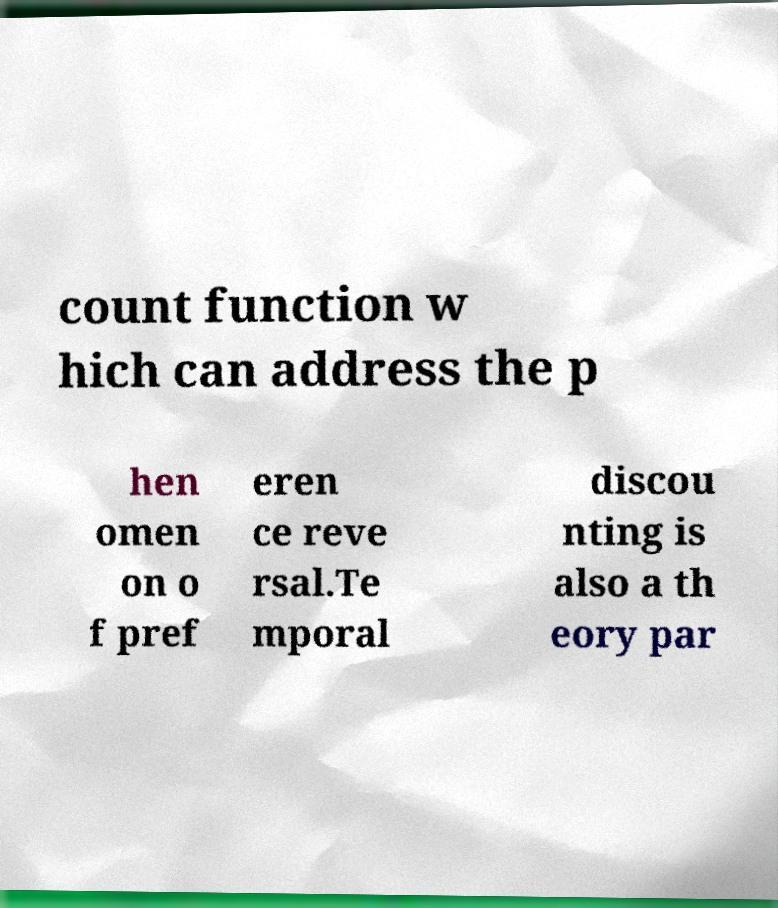Could you assist in decoding the text presented in this image and type it out clearly? count function w hich can address the p hen omen on o f pref eren ce reve rsal.Te mporal discou nting is also a th eory par 